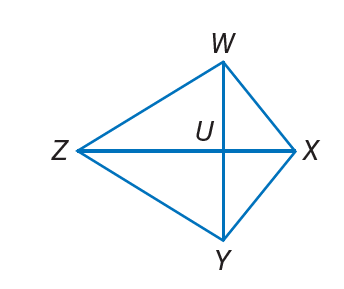Answer the mathemtical geometry problem and directly provide the correct option letter.
Question: W X Y Z is a kite. If m \angle W X Y = 13 x + 24, m \angle W Z Y = 35, and m \angle Z W X = 13 x + 14, find m \angle Z Y X.
Choices: A: 13 B: 24 C: 105 D: 210 C 